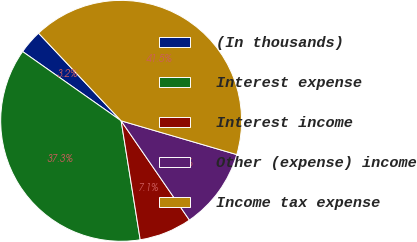<chart> <loc_0><loc_0><loc_500><loc_500><pie_chart><fcel>(In thousands)<fcel>Interest expense<fcel>Interest income<fcel>Other (expense) income<fcel>Income tax expense<nl><fcel>3.22%<fcel>37.28%<fcel>7.06%<fcel>10.89%<fcel>41.55%<nl></chart> 